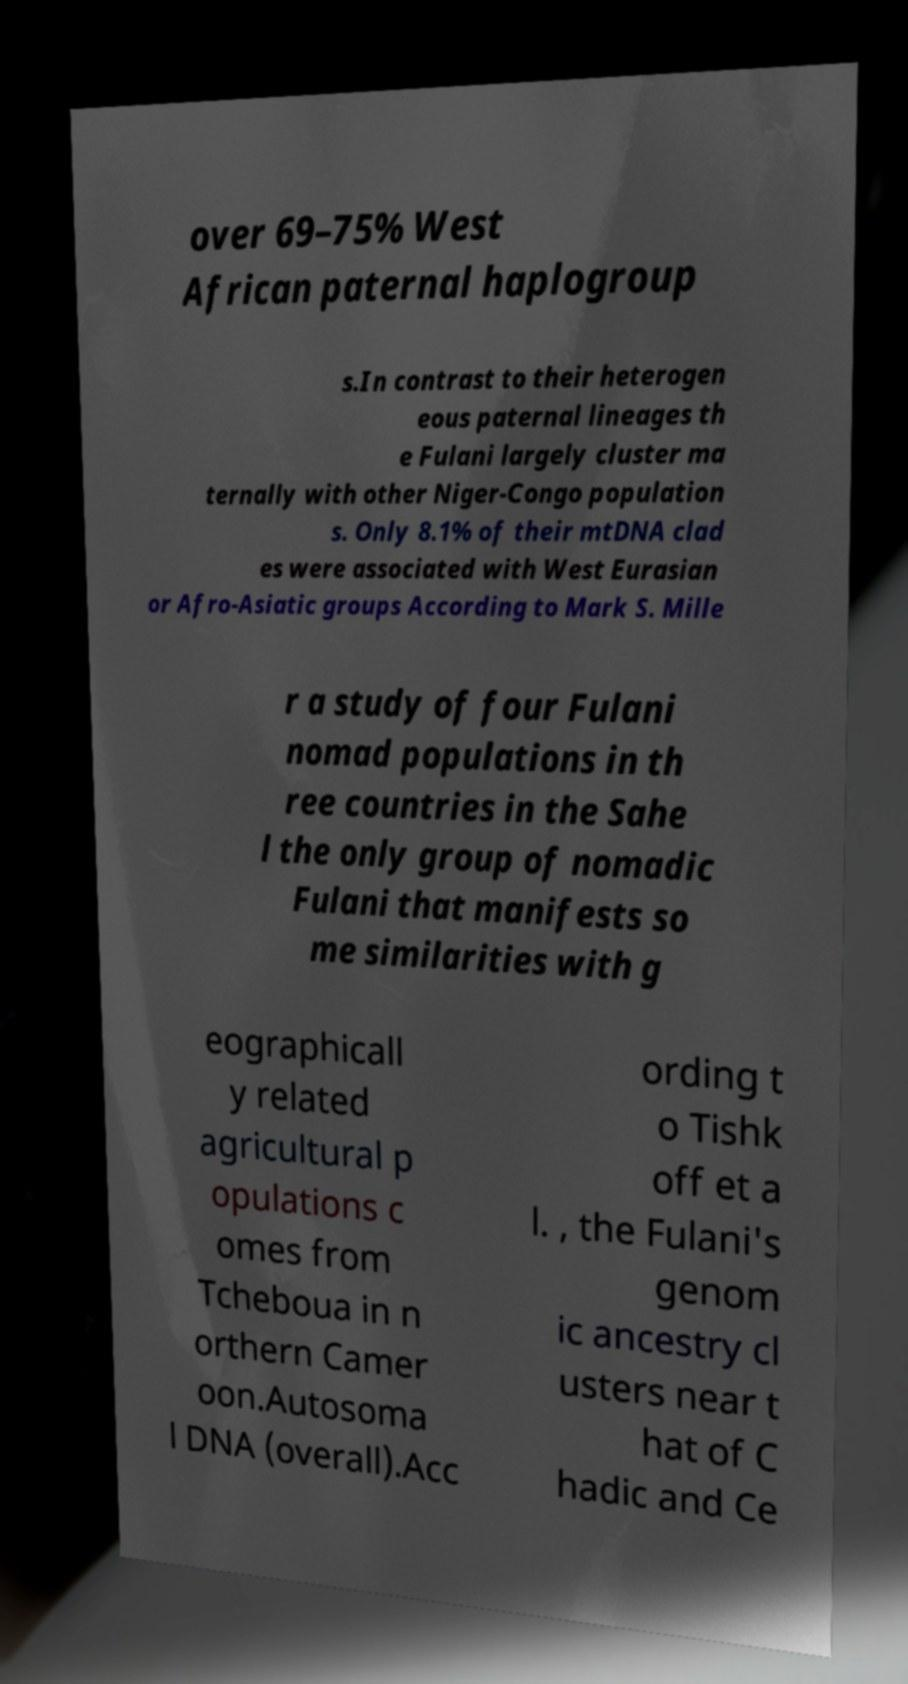There's text embedded in this image that I need extracted. Can you transcribe it verbatim? over 69–75% West African paternal haplogroup s.In contrast to their heterogen eous paternal lineages th e Fulani largely cluster ma ternally with other Niger-Congo population s. Only 8.1% of their mtDNA clad es were associated with West Eurasian or Afro-Asiatic groups According to Mark S. Mille r a study of four Fulani nomad populations in th ree countries in the Sahe l the only group of nomadic Fulani that manifests so me similarities with g eographicall y related agricultural p opulations c omes from Tcheboua in n orthern Camer oon.Autosoma l DNA (overall).Acc ording t o Tishk off et a l. , the Fulani's genom ic ancestry cl usters near t hat of C hadic and Ce 